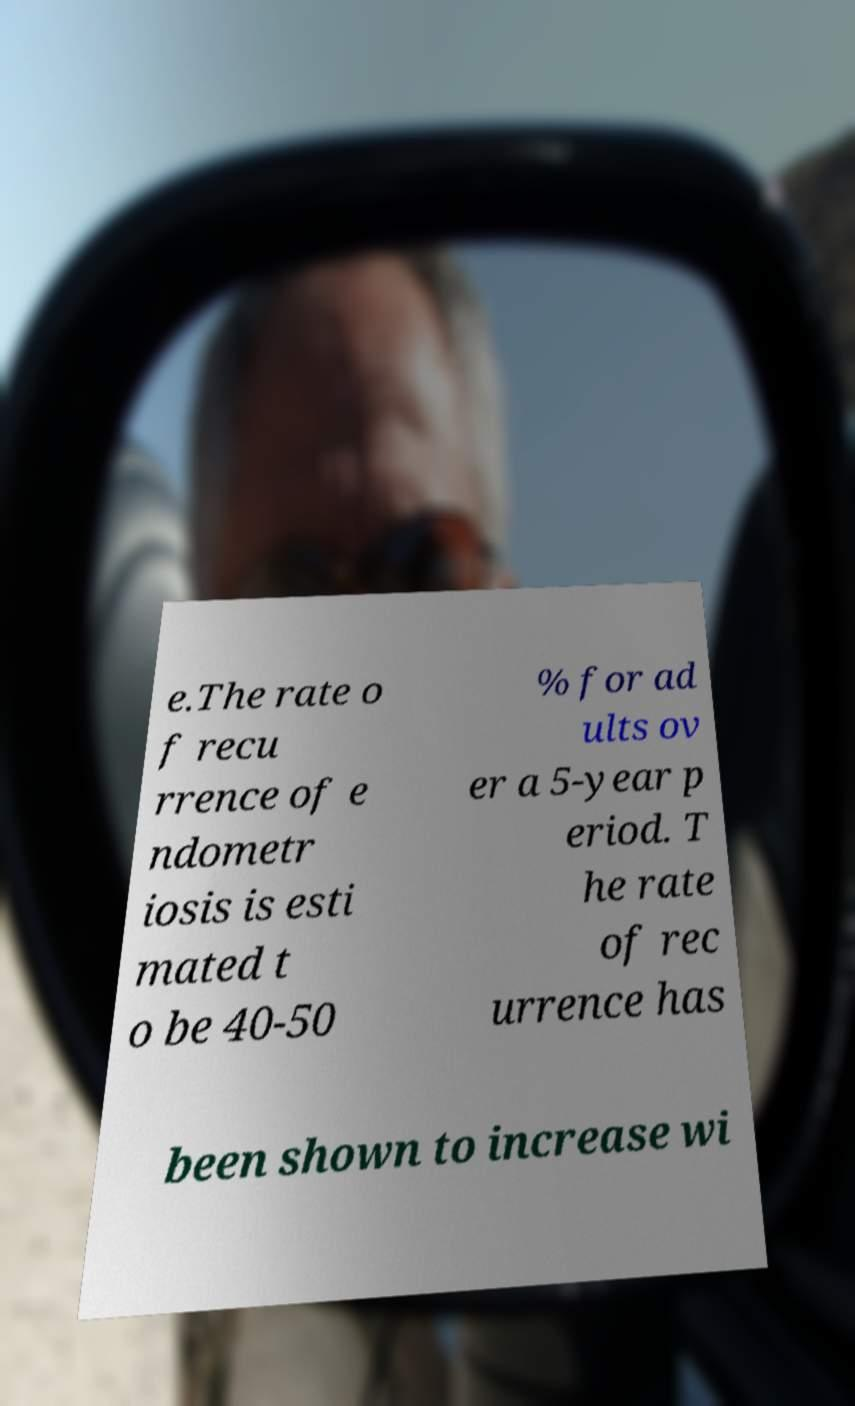Please identify and transcribe the text found in this image. e.The rate o f recu rrence of e ndometr iosis is esti mated t o be 40-50 % for ad ults ov er a 5-year p eriod. T he rate of rec urrence has been shown to increase wi 